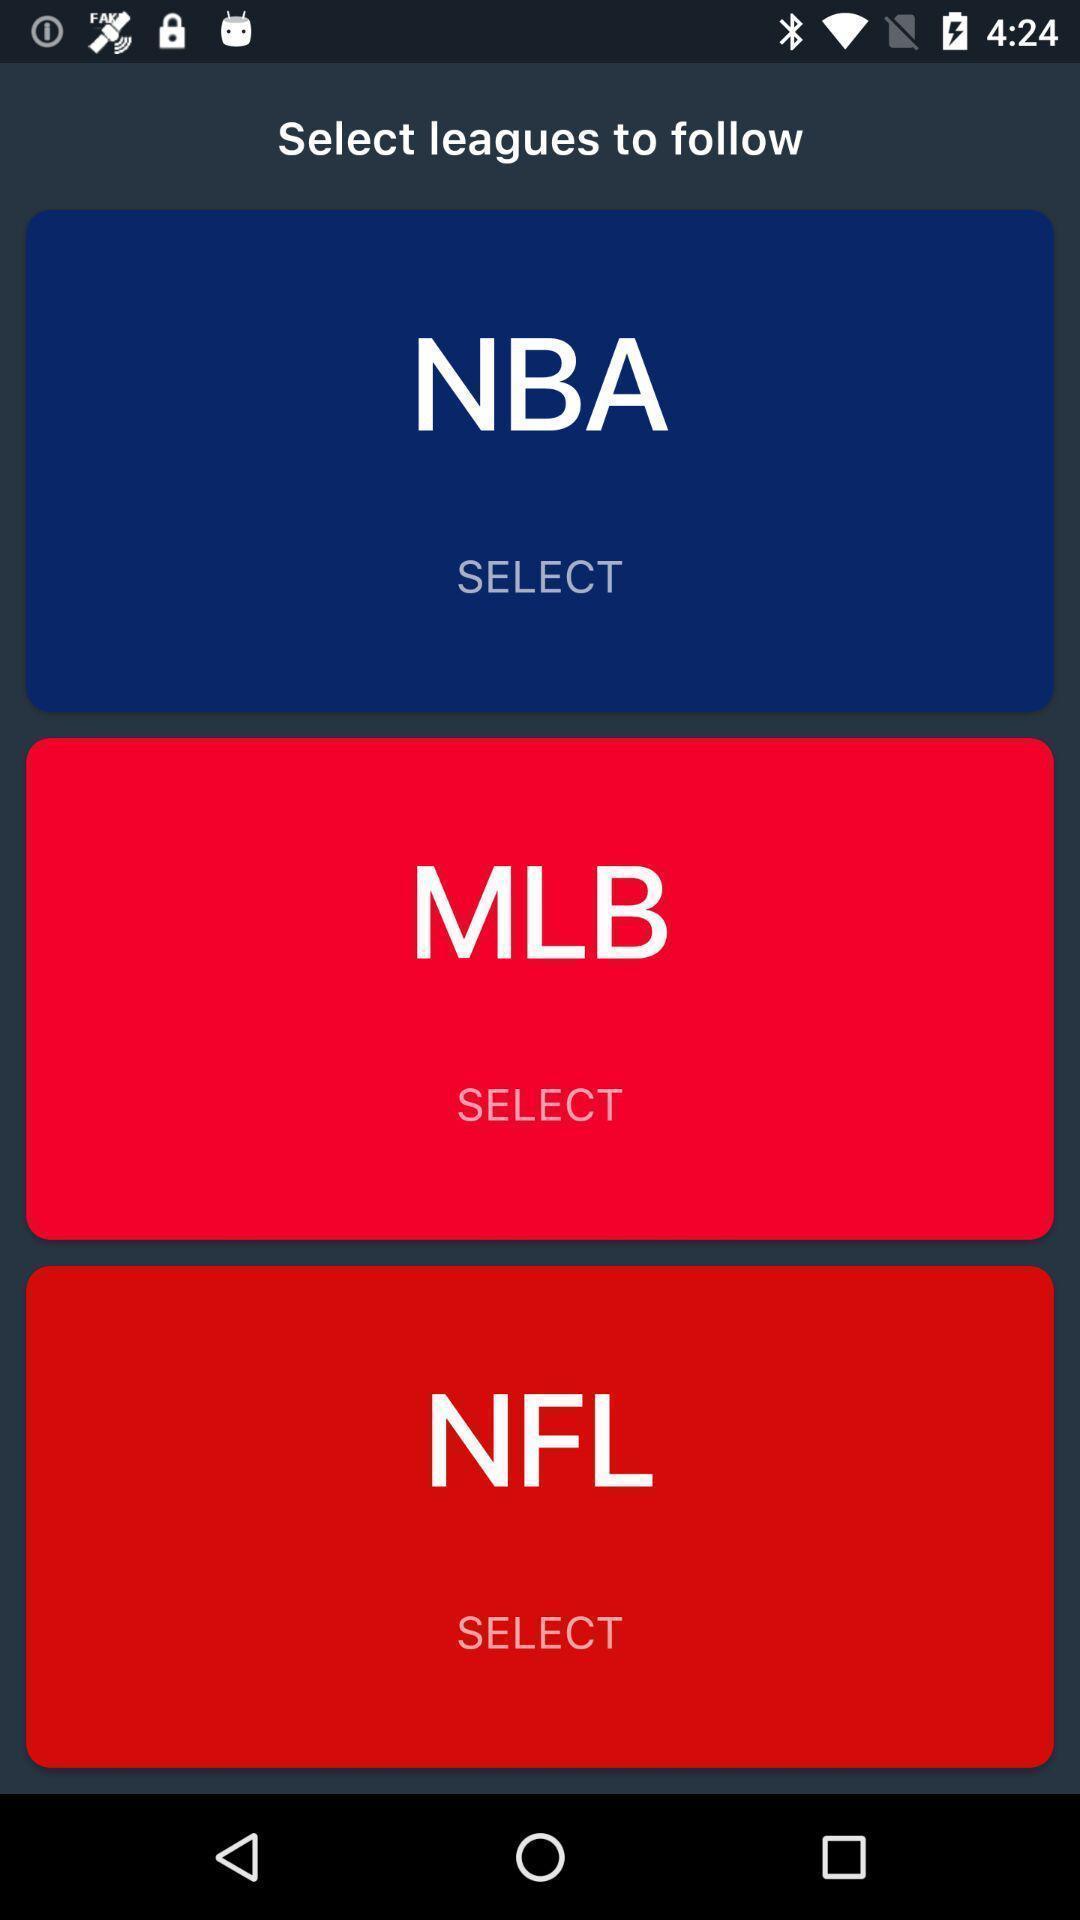What can you discern from this picture? Screen shows number of leagues. 